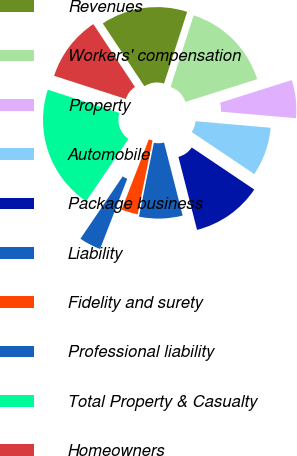Convert chart. <chart><loc_0><loc_0><loc_500><loc_500><pie_chart><fcel>Revenues<fcel>Workers' compensation<fcel>Property<fcel>Automobile<fcel>Package business<fcel>Liability<fcel>Fidelity and surety<fcel>Professional liability<fcel>Total Property & Casualty<fcel>Homeowners<nl><fcel>14.27%<fcel>15.16%<fcel>6.26%<fcel>8.04%<fcel>11.6%<fcel>7.15%<fcel>2.71%<fcel>3.6%<fcel>20.5%<fcel>10.71%<nl></chart> 